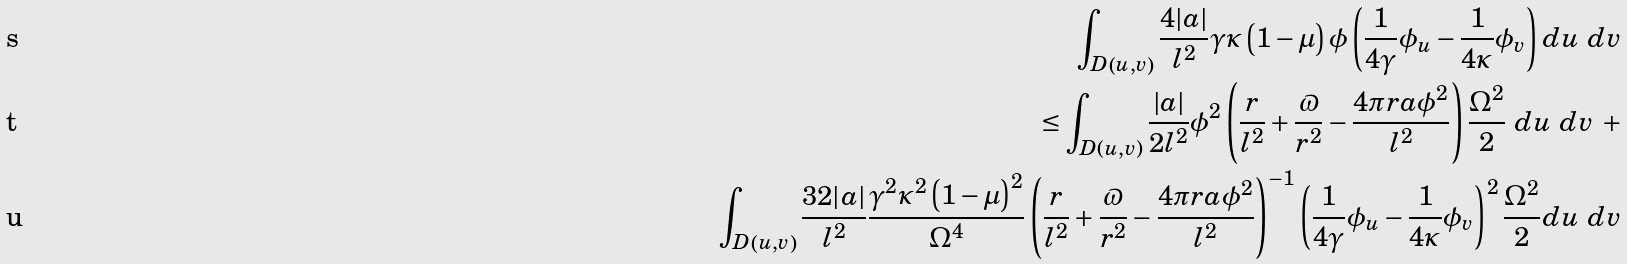Convert formula to latex. <formula><loc_0><loc_0><loc_500><loc_500>\int _ { D \left ( u , v \right ) } \frac { 4 | a | } { l ^ { 2 } } \gamma \kappa \left ( 1 - \mu \right ) \phi \left ( \frac { 1 } { 4 \gamma } \phi _ { u } - \frac { 1 } { 4 \kappa } \phi _ { v } \right ) d u \ d v \\ \leq \int _ { D \left ( u , v \right ) } \frac { | a | } { 2 l ^ { 2 } } \phi ^ { 2 } \left ( \frac { r } { l ^ { 2 } } + \frac { \varpi } { r ^ { 2 } } - \frac { 4 \pi r a \phi ^ { 2 } } { l ^ { 2 } } \right ) \frac { \Omega ^ { 2 } } { 2 } \ d u \ d v \ + \\ \int _ { D \left ( u , v \right ) } \frac { 3 2 | a | } { l ^ { 2 } } \frac { \gamma ^ { 2 } \kappa ^ { 2 } \left ( 1 - \mu \right ) ^ { 2 } } { \Omega ^ { 4 } } \left ( \frac { r } { l ^ { 2 } } + \frac { \varpi } { r ^ { 2 } } - \frac { 4 \pi r a \phi ^ { 2 } } { l ^ { 2 } } \right ) ^ { - 1 } \left ( \frac { 1 } { 4 \gamma } \phi _ { u } - \frac { 1 } { 4 \kappa } \phi _ { v } \right ) ^ { 2 } \frac { \Omega ^ { 2 } } { 2 } d u \ d v</formula> 